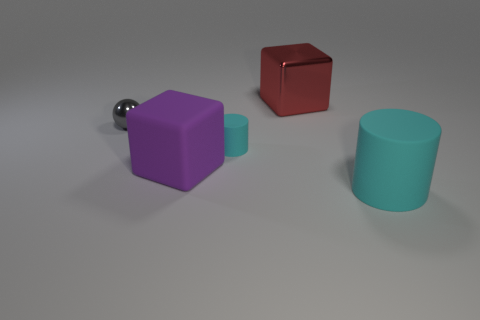Add 4 big cyan cylinders. How many objects exist? 9 Subtract all red cubes. How many cubes are left? 1 Subtract 1 cyan cylinders. How many objects are left? 4 Subtract all cubes. How many objects are left? 3 Subtract all red balls. Subtract all gray blocks. How many balls are left? 1 Subtract all gray shiny balls. Subtract all blocks. How many objects are left? 2 Add 2 large purple blocks. How many large purple blocks are left? 3 Add 5 blue shiny cubes. How many blue shiny cubes exist? 5 